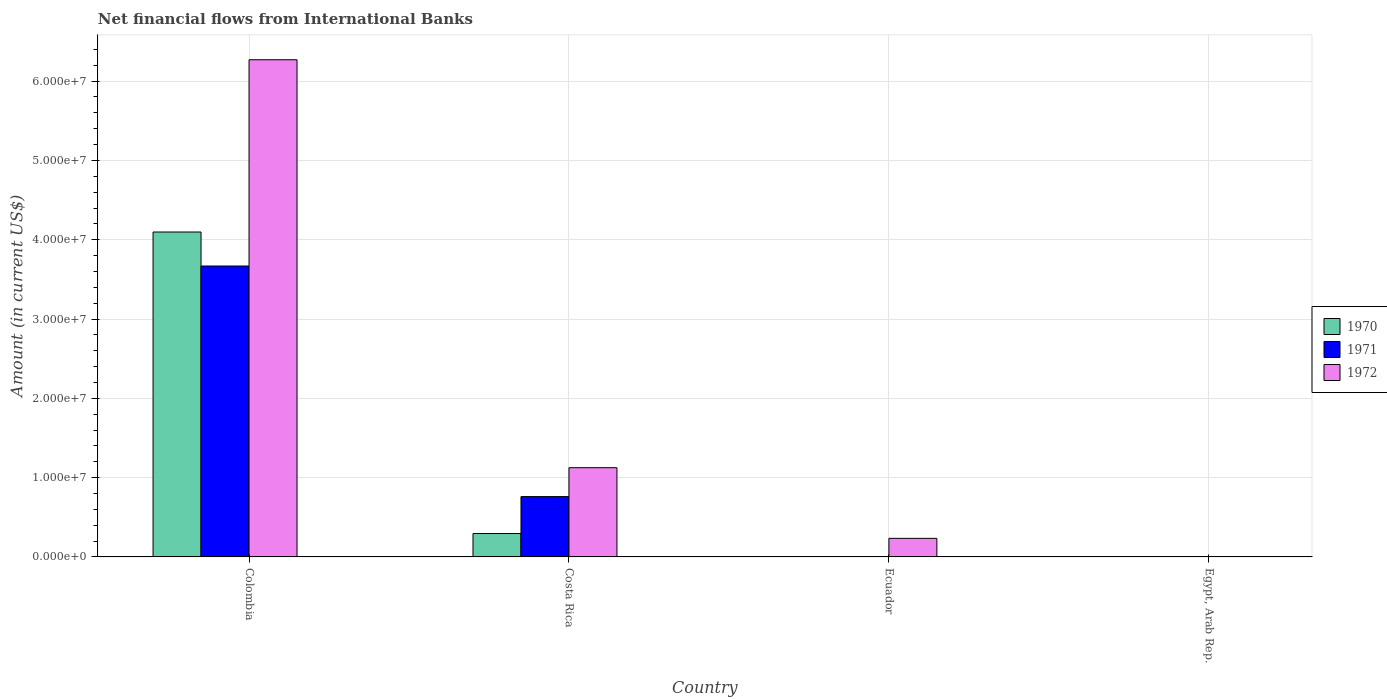How many bars are there on the 1st tick from the left?
Ensure brevity in your answer.  3. How many bars are there on the 3rd tick from the right?
Your response must be concise. 3. In how many cases, is the number of bars for a given country not equal to the number of legend labels?
Give a very brief answer. 2. Across all countries, what is the maximum net financial aid flows in 1971?
Provide a short and direct response. 3.67e+07. What is the total net financial aid flows in 1970 in the graph?
Offer a very short reply. 4.39e+07. What is the difference between the net financial aid flows in 1972 in Colombia and that in Ecuador?
Your response must be concise. 6.04e+07. What is the difference between the net financial aid flows in 1972 in Colombia and the net financial aid flows in 1971 in Egypt, Arab Rep.?
Give a very brief answer. 6.27e+07. What is the average net financial aid flows in 1972 per country?
Your answer should be very brief. 1.91e+07. What is the difference between the net financial aid flows of/in 1970 and net financial aid flows of/in 1972 in Colombia?
Make the answer very short. -2.17e+07. In how many countries, is the net financial aid flows in 1970 greater than 14000000 US$?
Offer a terse response. 1. What is the ratio of the net financial aid flows in 1972 in Costa Rica to that in Ecuador?
Ensure brevity in your answer.  4.8. Is the net financial aid flows in 1972 in Colombia less than that in Costa Rica?
Your response must be concise. No. What is the difference between the highest and the second highest net financial aid flows in 1972?
Ensure brevity in your answer.  5.14e+07. What is the difference between the highest and the lowest net financial aid flows in 1971?
Keep it short and to the point. 3.67e+07. Is the sum of the net financial aid flows in 1972 in Costa Rica and Ecuador greater than the maximum net financial aid flows in 1970 across all countries?
Your answer should be compact. No. How many bars are there?
Keep it short and to the point. 7. How many countries are there in the graph?
Provide a succinct answer. 4. Does the graph contain grids?
Provide a short and direct response. Yes. Where does the legend appear in the graph?
Your response must be concise. Center right. What is the title of the graph?
Offer a very short reply. Net financial flows from International Banks. What is the label or title of the X-axis?
Give a very brief answer. Country. What is the Amount (in current US$) of 1970 in Colombia?
Provide a succinct answer. 4.10e+07. What is the Amount (in current US$) of 1971 in Colombia?
Provide a succinct answer. 3.67e+07. What is the Amount (in current US$) of 1972 in Colombia?
Your answer should be compact. 6.27e+07. What is the Amount (in current US$) in 1970 in Costa Rica?
Provide a short and direct response. 2.95e+06. What is the Amount (in current US$) in 1971 in Costa Rica?
Offer a very short reply. 7.61e+06. What is the Amount (in current US$) of 1972 in Costa Rica?
Provide a succinct answer. 1.13e+07. What is the Amount (in current US$) of 1971 in Ecuador?
Your response must be concise. 0. What is the Amount (in current US$) of 1972 in Ecuador?
Your answer should be very brief. 2.34e+06. What is the Amount (in current US$) of 1971 in Egypt, Arab Rep.?
Your response must be concise. 0. What is the Amount (in current US$) of 1972 in Egypt, Arab Rep.?
Your response must be concise. 0. Across all countries, what is the maximum Amount (in current US$) in 1970?
Your answer should be compact. 4.10e+07. Across all countries, what is the maximum Amount (in current US$) in 1971?
Your answer should be very brief. 3.67e+07. Across all countries, what is the maximum Amount (in current US$) in 1972?
Offer a terse response. 6.27e+07. Across all countries, what is the minimum Amount (in current US$) of 1971?
Provide a succinct answer. 0. What is the total Amount (in current US$) of 1970 in the graph?
Offer a very short reply. 4.39e+07. What is the total Amount (in current US$) of 1971 in the graph?
Give a very brief answer. 4.43e+07. What is the total Amount (in current US$) in 1972 in the graph?
Ensure brevity in your answer.  7.63e+07. What is the difference between the Amount (in current US$) in 1970 in Colombia and that in Costa Rica?
Ensure brevity in your answer.  3.80e+07. What is the difference between the Amount (in current US$) in 1971 in Colombia and that in Costa Rica?
Provide a succinct answer. 2.91e+07. What is the difference between the Amount (in current US$) in 1972 in Colombia and that in Costa Rica?
Ensure brevity in your answer.  5.14e+07. What is the difference between the Amount (in current US$) in 1972 in Colombia and that in Ecuador?
Provide a succinct answer. 6.04e+07. What is the difference between the Amount (in current US$) of 1972 in Costa Rica and that in Ecuador?
Your response must be concise. 8.91e+06. What is the difference between the Amount (in current US$) in 1970 in Colombia and the Amount (in current US$) in 1971 in Costa Rica?
Your response must be concise. 3.34e+07. What is the difference between the Amount (in current US$) in 1970 in Colombia and the Amount (in current US$) in 1972 in Costa Rica?
Your response must be concise. 2.97e+07. What is the difference between the Amount (in current US$) in 1971 in Colombia and the Amount (in current US$) in 1972 in Costa Rica?
Your answer should be very brief. 2.54e+07. What is the difference between the Amount (in current US$) in 1970 in Colombia and the Amount (in current US$) in 1972 in Ecuador?
Your answer should be compact. 3.86e+07. What is the difference between the Amount (in current US$) of 1971 in Colombia and the Amount (in current US$) of 1972 in Ecuador?
Provide a short and direct response. 3.43e+07. What is the difference between the Amount (in current US$) in 1971 in Costa Rica and the Amount (in current US$) in 1972 in Ecuador?
Your answer should be compact. 5.27e+06. What is the average Amount (in current US$) of 1970 per country?
Offer a very short reply. 1.10e+07. What is the average Amount (in current US$) of 1971 per country?
Provide a succinct answer. 1.11e+07. What is the average Amount (in current US$) in 1972 per country?
Provide a succinct answer. 1.91e+07. What is the difference between the Amount (in current US$) in 1970 and Amount (in current US$) in 1971 in Colombia?
Offer a very short reply. 4.29e+06. What is the difference between the Amount (in current US$) of 1970 and Amount (in current US$) of 1972 in Colombia?
Ensure brevity in your answer.  -2.17e+07. What is the difference between the Amount (in current US$) in 1971 and Amount (in current US$) in 1972 in Colombia?
Keep it short and to the point. -2.60e+07. What is the difference between the Amount (in current US$) in 1970 and Amount (in current US$) in 1971 in Costa Rica?
Offer a very short reply. -4.66e+06. What is the difference between the Amount (in current US$) in 1970 and Amount (in current US$) in 1972 in Costa Rica?
Give a very brief answer. -8.30e+06. What is the difference between the Amount (in current US$) in 1971 and Amount (in current US$) in 1972 in Costa Rica?
Provide a succinct answer. -3.64e+06. What is the ratio of the Amount (in current US$) of 1970 in Colombia to that in Costa Rica?
Provide a short and direct response. 13.88. What is the ratio of the Amount (in current US$) of 1971 in Colombia to that in Costa Rica?
Make the answer very short. 4.82. What is the ratio of the Amount (in current US$) in 1972 in Colombia to that in Costa Rica?
Your response must be concise. 5.57. What is the ratio of the Amount (in current US$) in 1972 in Colombia to that in Ecuador?
Your response must be concise. 26.77. What is the ratio of the Amount (in current US$) of 1972 in Costa Rica to that in Ecuador?
Make the answer very short. 4.8. What is the difference between the highest and the second highest Amount (in current US$) in 1972?
Offer a very short reply. 5.14e+07. What is the difference between the highest and the lowest Amount (in current US$) in 1970?
Ensure brevity in your answer.  4.10e+07. What is the difference between the highest and the lowest Amount (in current US$) of 1971?
Provide a succinct answer. 3.67e+07. What is the difference between the highest and the lowest Amount (in current US$) of 1972?
Ensure brevity in your answer.  6.27e+07. 